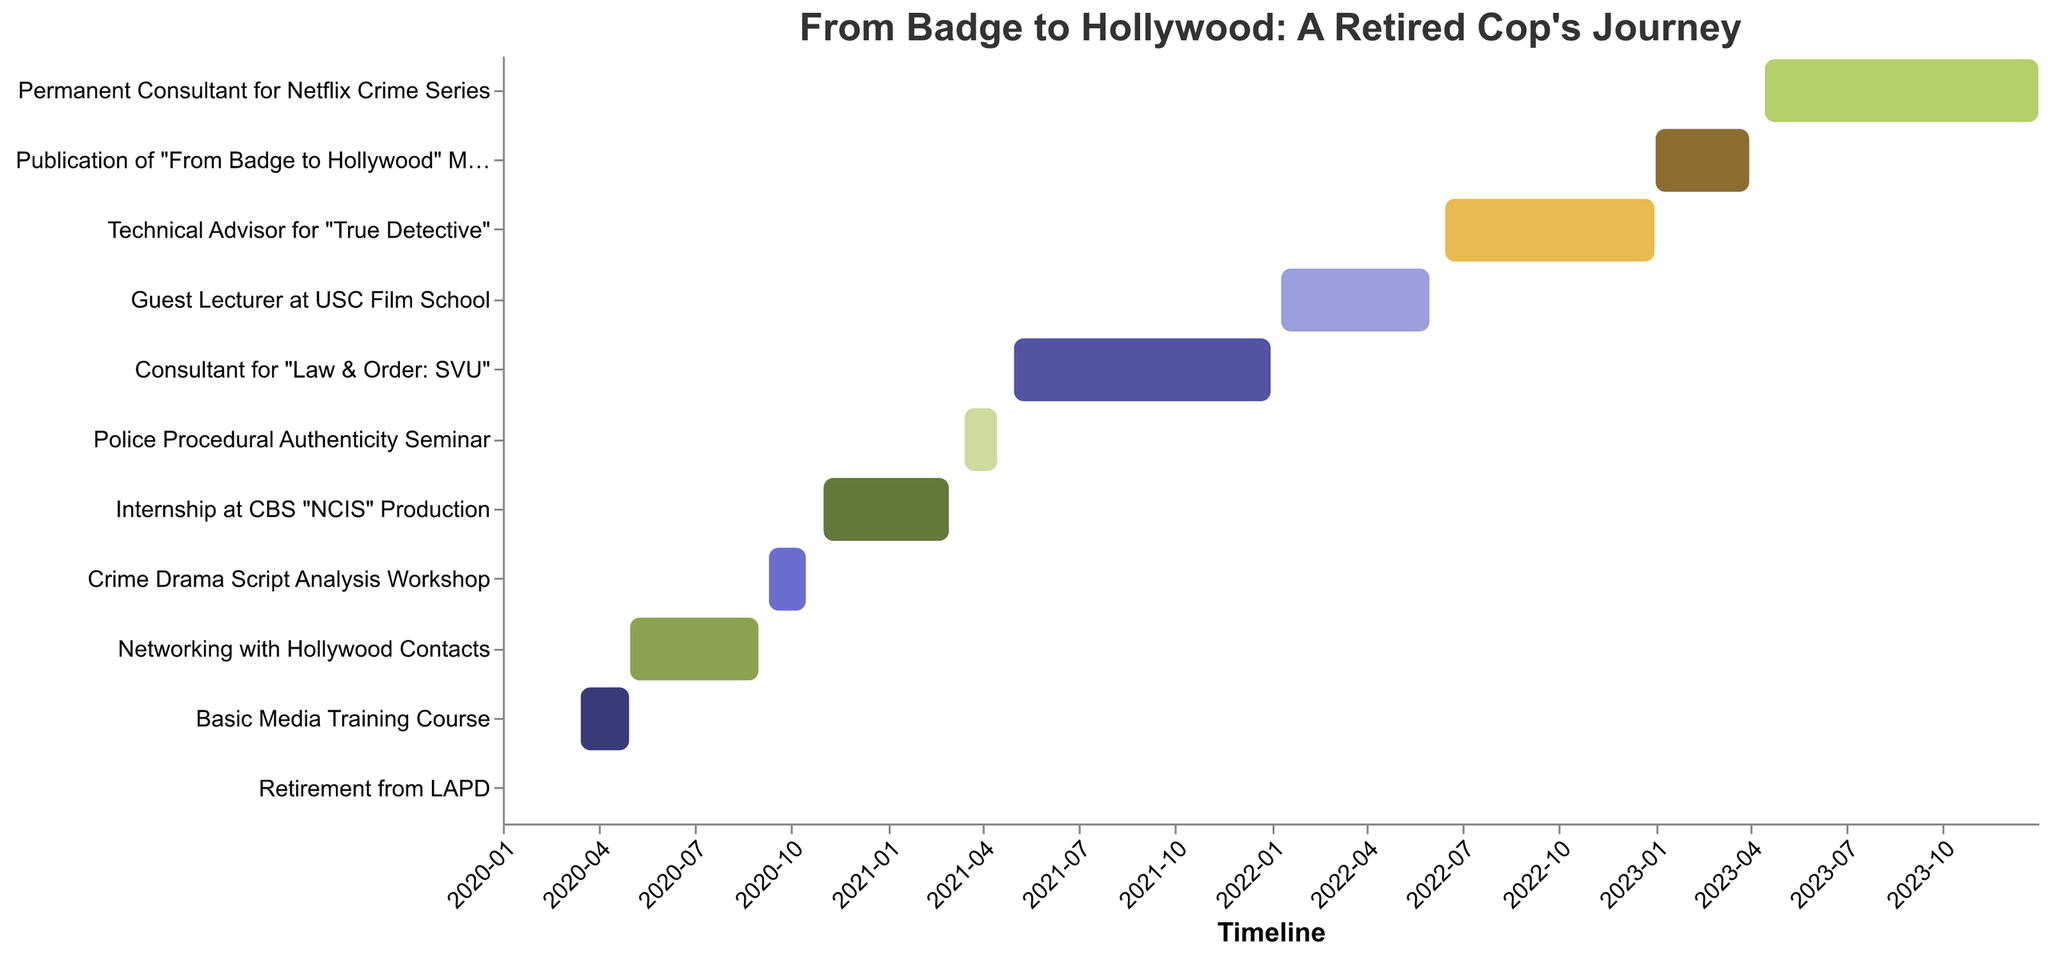What's the title of the Gantt Chart? The title is located at the top of the chart in bold and larger font compared to other text elements, allowing easy identification.
Answer: From Badge to Hollywood: A Retired Cop's Journey How long did the 'Basic Media Training Course' last? Check the 'Basic Media Training Course' bar on the Gantt chart and look at the start and end dates, which range from 2020-03-15 to 2020-04-30. Calculate the duration.
Answer: 1.5 months Which event started immediately after the 'Basic Media Training Course'? Look for tasks starting after 2020-04-30. Identify that 'Networking with Hollywood Contacts' begins on 2020-05-01.
Answer: Networking with Hollywood Contacts How many tasks were completed in the year 2022? Identify all the tasks within the year 2022 by examining their start and end dates. Three tasks fall entirely or partially within this year.
Answer: 3 tasks Which task had the shortest duration? Compare the start and end dates for each task to find the task lasting the least amount of time. 'Retirement from LAPD' is the shortest, lasting only one day.
Answer: Retirement from LAPD What are the start and end dates for the 'Permanent Consultant for Netflix Crime Series' task? Locate this task on the chart and read the tooltip for the start and end dates, which are 2023-04-15 and 2023-12-31.
Answer: 2023-04-15 to 2023-12-31 Which task involved working on the 'NCIS' production? The task related to 'NCIS' production is indicated in one of the bars: 'Internship at CBS "NCIS" Production'.
Answer: Internship at CBS "NCIS" Production How many months were spent as a 'Guest Lecturer at USC Film School'? Identify the start and end dates from the task bar: 2022-01-10 to 2022-05-31. Calculate the duration in months.
Answer: 4.5 months Compare the durations of 'Crime Drama Script Analysis Workshop' and 'Publication of "From Badge to Hollywood" Memoir'. Which was longer? Determine the durations by checking the start and end dates of each: Workshop (2020-09-10 to 2020-10-15) and Memoir (2023-01-01 to 2023-03-31). Duration calculation shows Memoir is longer.
Answer: Publication of "From Badge to Hollywood" Memoir What tasks were conducted after 'Consultant for "Law & Order: SVU"' ended? Check for tasks starting after 2021-12-31. Identify those following the end of 'Law & Order: SVU' consultancy.
Answer: Guest Lecturer at USC Film School, Technical Advisor for "True Detective", Publication of "From Badge to Hollywood" Memoir, Permanent Consultant for Netflix Crime Series 